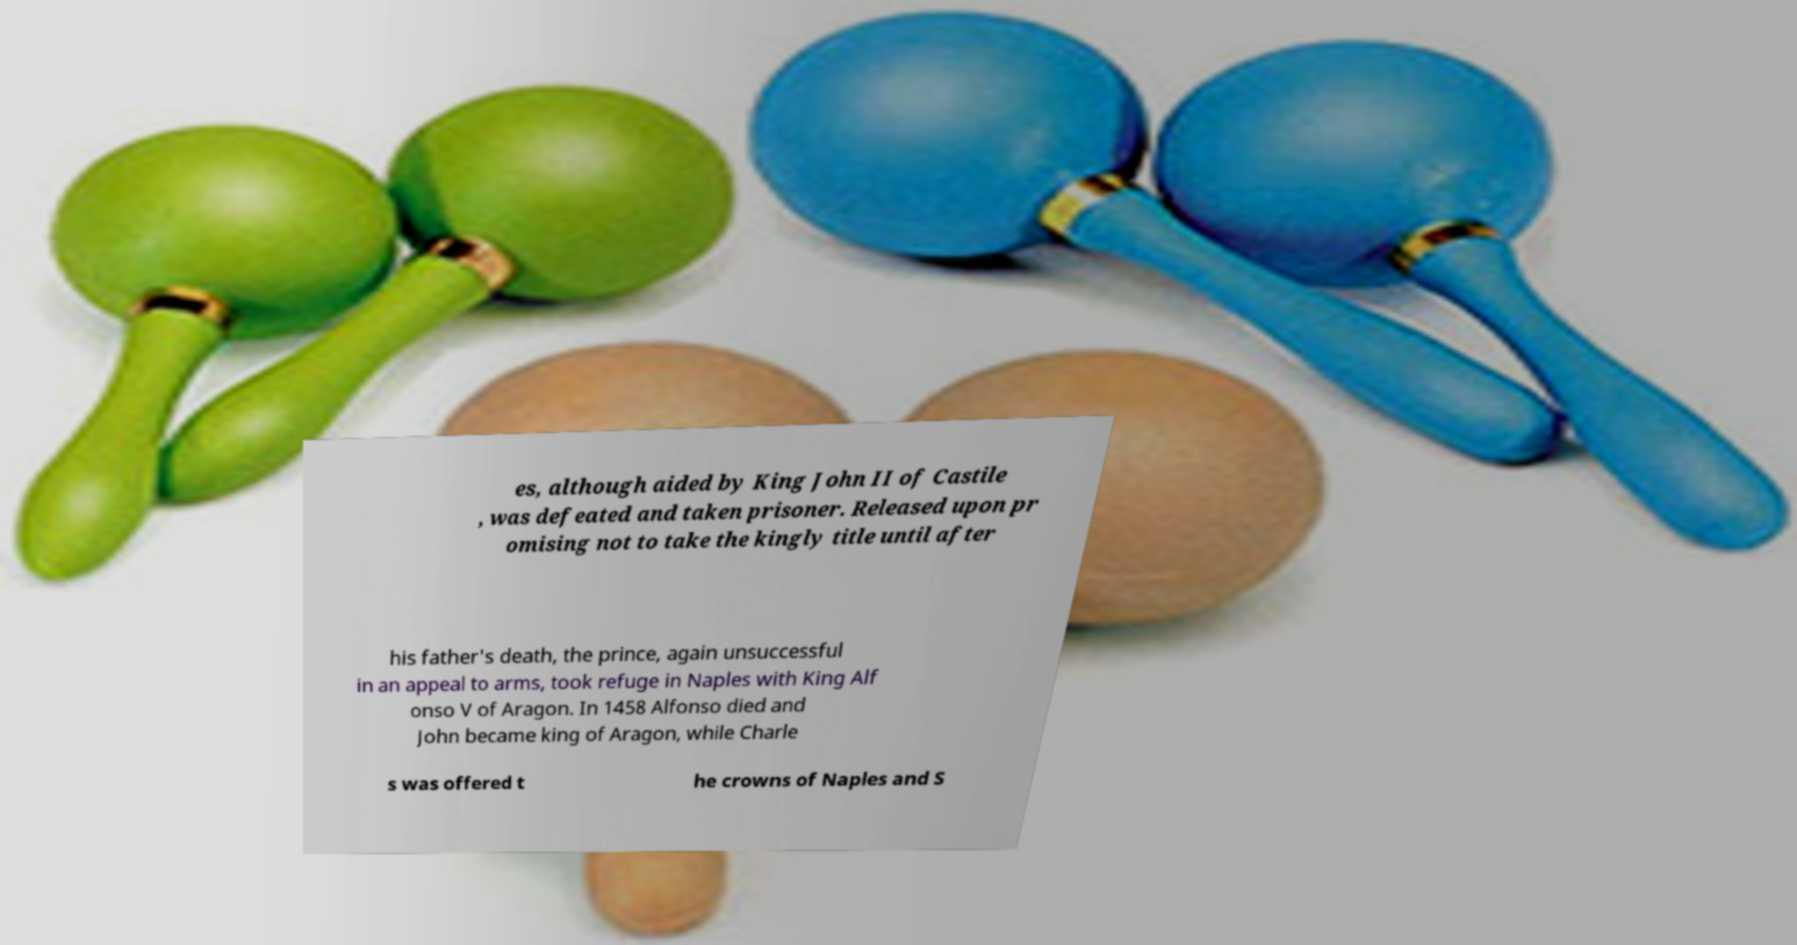There's text embedded in this image that I need extracted. Can you transcribe it verbatim? es, although aided by King John II of Castile , was defeated and taken prisoner. Released upon pr omising not to take the kingly title until after his father's death, the prince, again unsuccessful in an appeal to arms, took refuge in Naples with King Alf onso V of Aragon. In 1458 Alfonso died and John became king of Aragon, while Charle s was offered t he crowns of Naples and S 